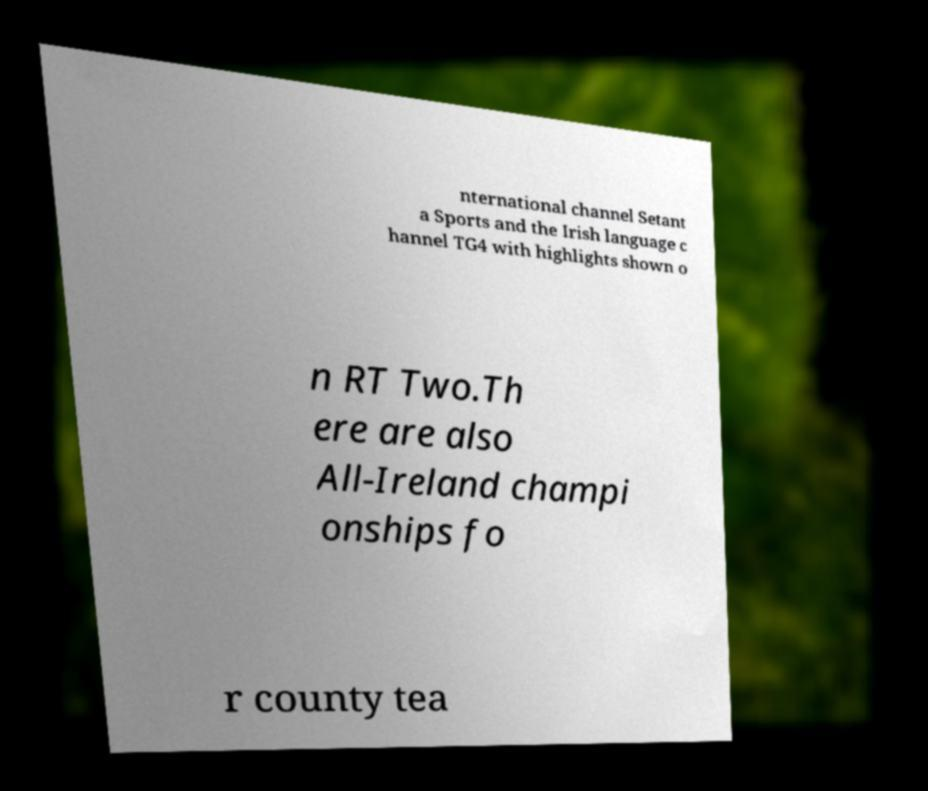There's text embedded in this image that I need extracted. Can you transcribe it verbatim? nternational channel Setant a Sports and the Irish language c hannel TG4 with highlights shown o n RT Two.Th ere are also All-Ireland champi onships fo r county tea 